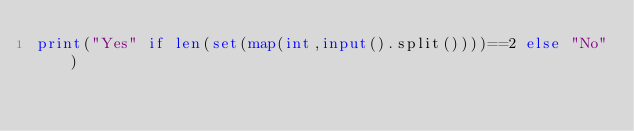Convert code to text. <code><loc_0><loc_0><loc_500><loc_500><_Python_>print("Yes" if len(set(map(int,input().split())))==2 else "No")</code> 